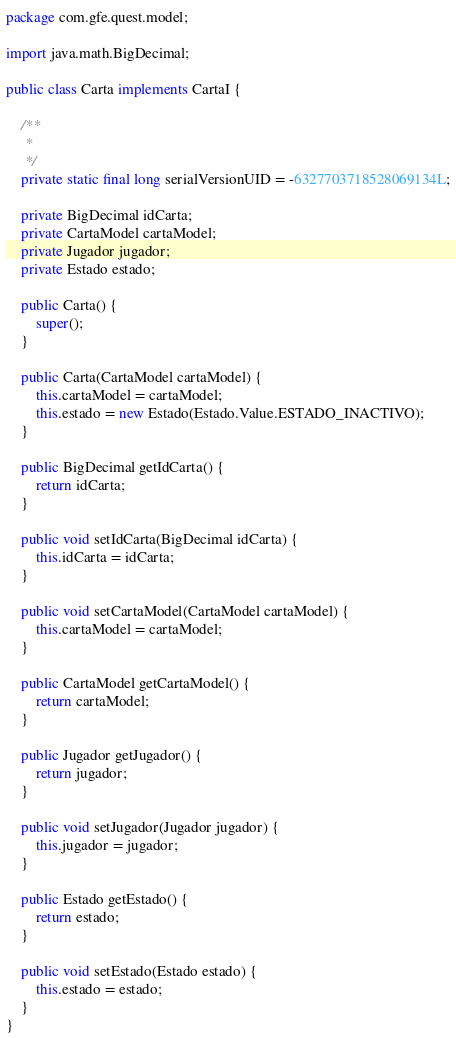Convert code to text. <code><loc_0><loc_0><loc_500><loc_500><_Java_>package com.gfe.quest.model;

import java.math.BigDecimal;

public class Carta implements CartaI {
	
	/**
	 * 
	 */
	private static final long serialVersionUID = -6327703718528069134L;
	
	private BigDecimal idCarta;
	private CartaModel cartaModel;
	private Jugador jugador;
	private Estado estado;
	
	public Carta() {
		super();
	}
	
	public Carta(CartaModel cartaModel) {
		this.cartaModel = cartaModel;
		this.estado = new Estado(Estado.Value.ESTADO_INACTIVO);
	}
	
	public BigDecimal getIdCarta() {
		return idCarta;
	}

	public void setIdCarta(BigDecimal idCarta) {
		this.idCarta = idCarta;
	}

	public void setCartaModel(CartaModel cartaModel) {
		this.cartaModel = cartaModel;
	}

	public CartaModel getCartaModel() {
		return cartaModel;
	}

	public Jugador getJugador() {
		return jugador;
	}

	public void setJugador(Jugador jugador) {
		this.jugador = jugador;
	}

	public Estado getEstado() {
		return estado;
	}

	public void setEstado(Estado estado) {
		this.estado = estado;
	}
}
</code> 